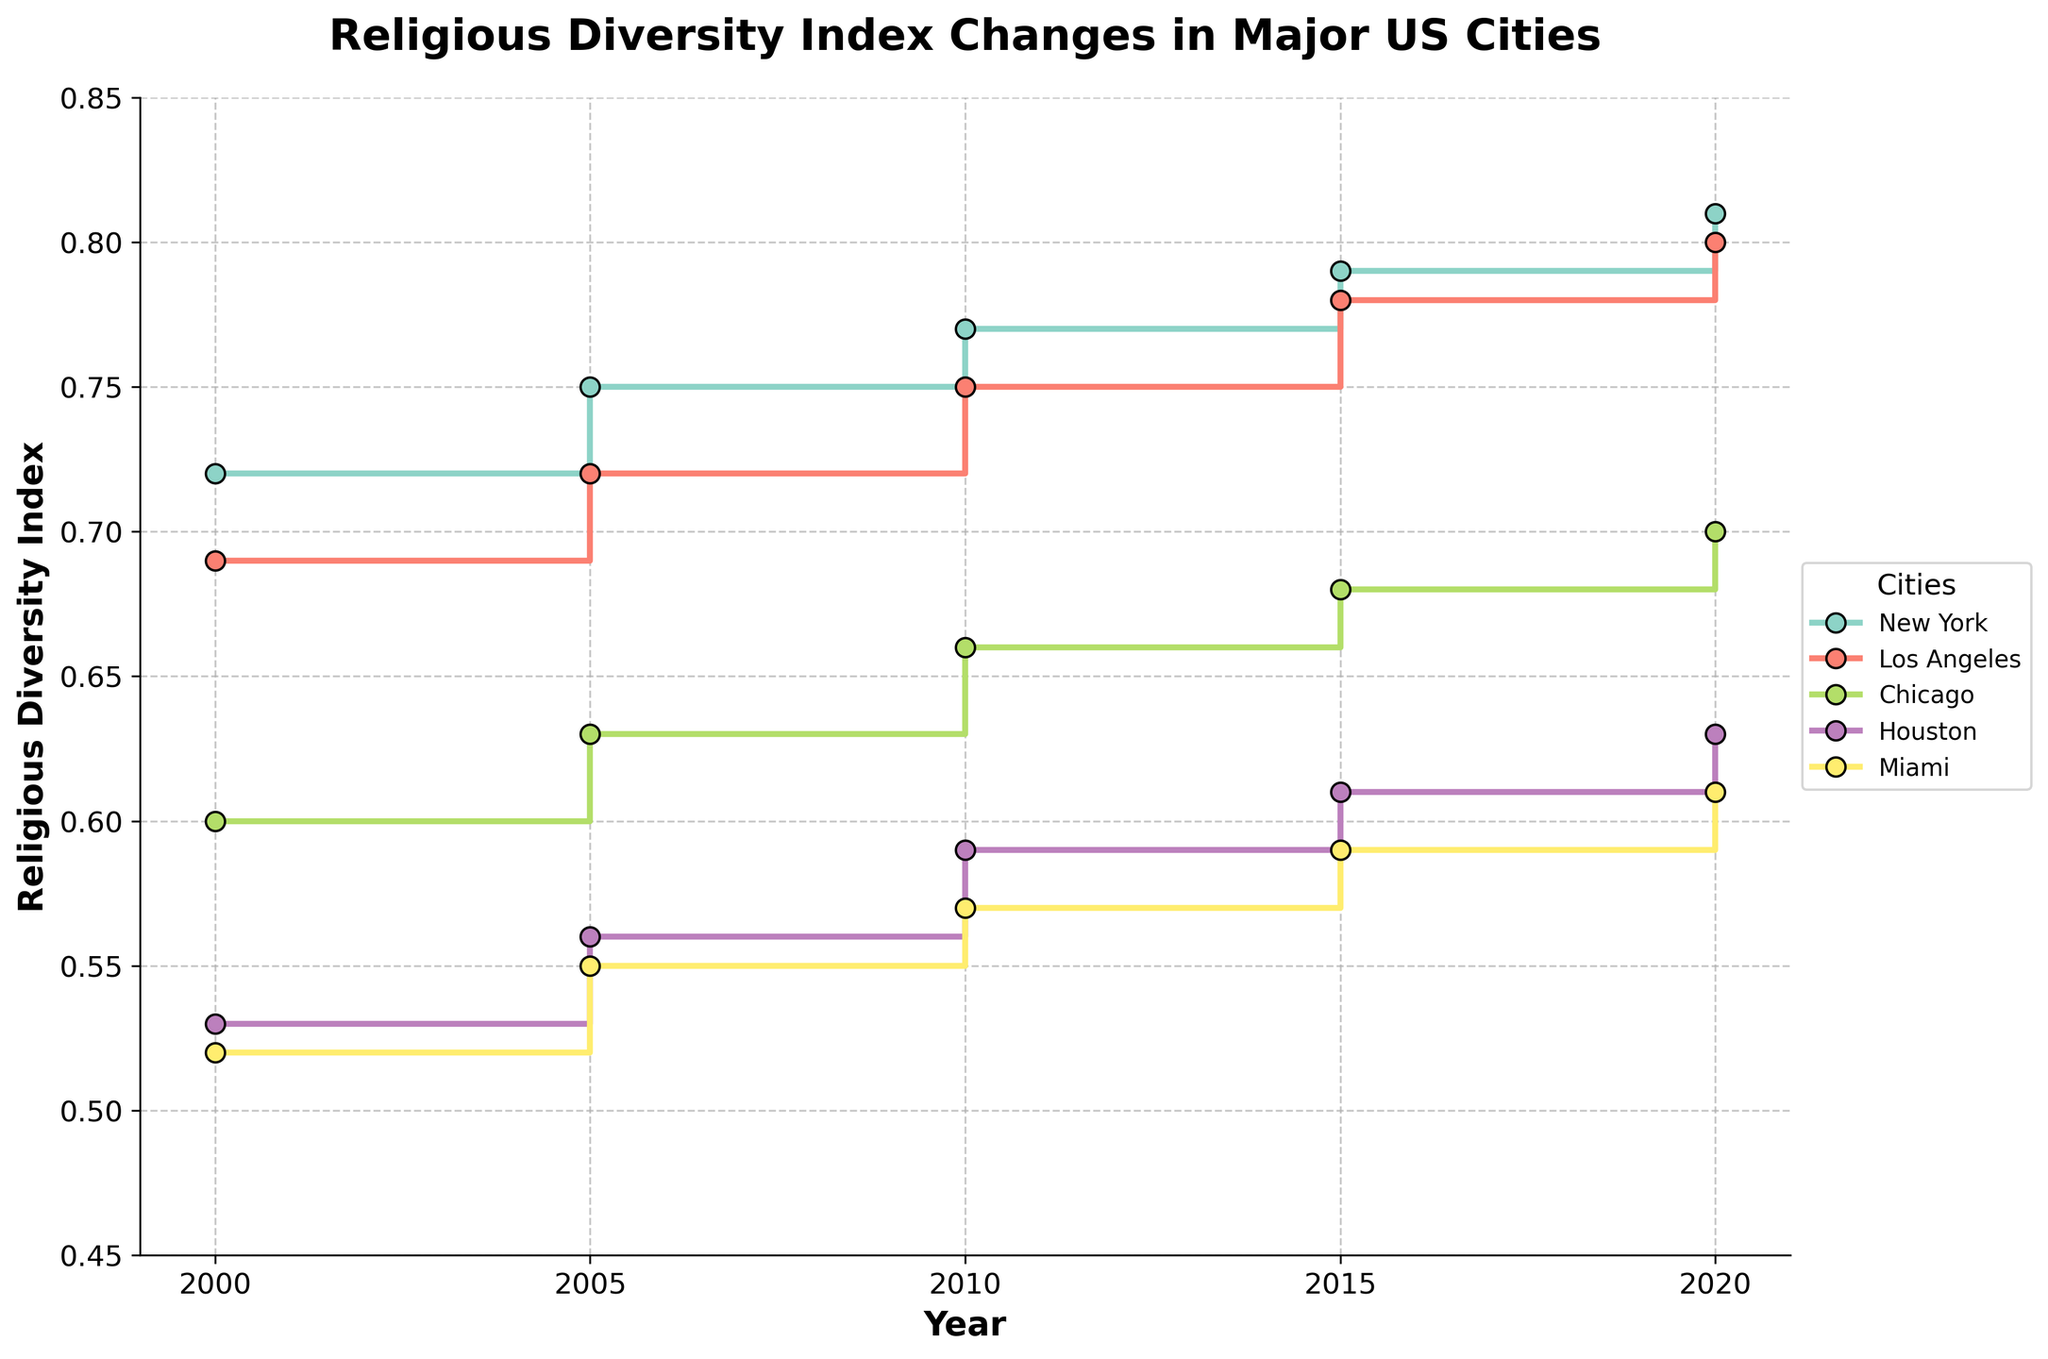what is the title of the figure? The title is at the top of the figure and describes what the data represents, which in this case, is the change in religious diversity over time in major US cities.
Answer: Religious Diversity Index Changes in Major US Cities Between which years does the data span? The x-axis of the plot is labeled "Year," and the ticks show the years covered. The plot spans from the first tick mark at 2000 to the last tick mark at 2020.
Answer: 2000 to 2020 Which city showed the highest final religious diversity index in 2020? To answer this, look at the values at the 2020 tick for each city on the step lines. The highest value is represented by the topmost line, which corresponds to New York.
Answer: New York Which two cities had the closest final religious diversity indexes in 2000? Comparing the step values at the 2000 tick for all cities, Chicago and Houston have the closest values, which visually appear to be close together and between 0.50 and 0.60.
Answer: Chicago and Houston What trend can you see for New York's religious diversity index from 2000 to 2020? Look at the stepped line for New York from 2000 to 2020. The line steadily increases step-by-step, indicating a consistent upward trend in religious diversity.
Answer: Steady increase By how many points did the Los Angeles final religious diversity index increase between 2000 and 2020? Look at the 2000 and 2020 values of Los Angeles on the stepped line. Subtract the 2000 value (0.69) from the 2020 value (0.80). The increase is 0.80 - 0.69.
Answer: 0.11 Which city had the smallest change in religious diversity index between 2015 and 2020? Examine the changes from 2015 to 2020 for all cities. Miami shows the smallest increase as its line has the shortest vertical distance between these years.
Answer: Miami Did any city experience a decrease in religious diversity index from one period to another? Check if any step line shows a downward trend in any segment. All lines either stay flat or trend upwards; none show a decrease.
Answer: No What was the religious diversity index of Houston in 2005? Follow the step line for Houston to 2005. The value at this point is between 0.53 and 0.56.
Answer: Approximately 0.56 